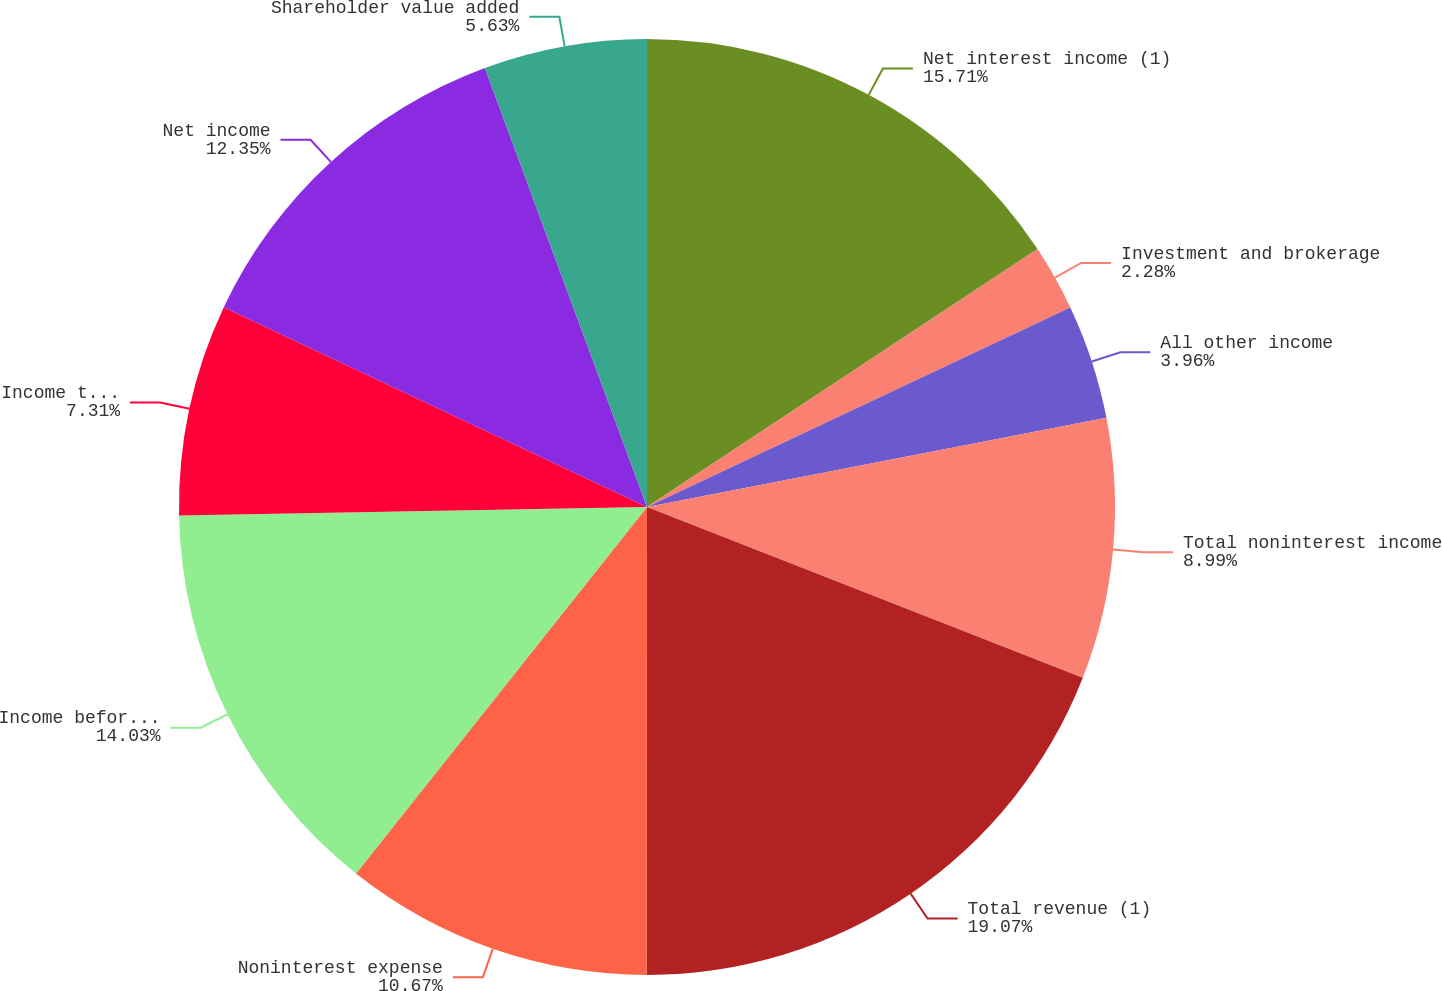Convert chart to OTSL. <chart><loc_0><loc_0><loc_500><loc_500><pie_chart><fcel>Net interest income (1)<fcel>Investment and brokerage<fcel>All other income<fcel>Total noninterest income<fcel>Total revenue (1)<fcel>Noninterest expense<fcel>Income before income taxes (1)<fcel>Income tax expense<fcel>Net income<fcel>Shareholder value added<nl><fcel>15.71%<fcel>2.28%<fcel>3.96%<fcel>8.99%<fcel>19.07%<fcel>10.67%<fcel>14.03%<fcel>7.31%<fcel>12.35%<fcel>5.63%<nl></chart> 